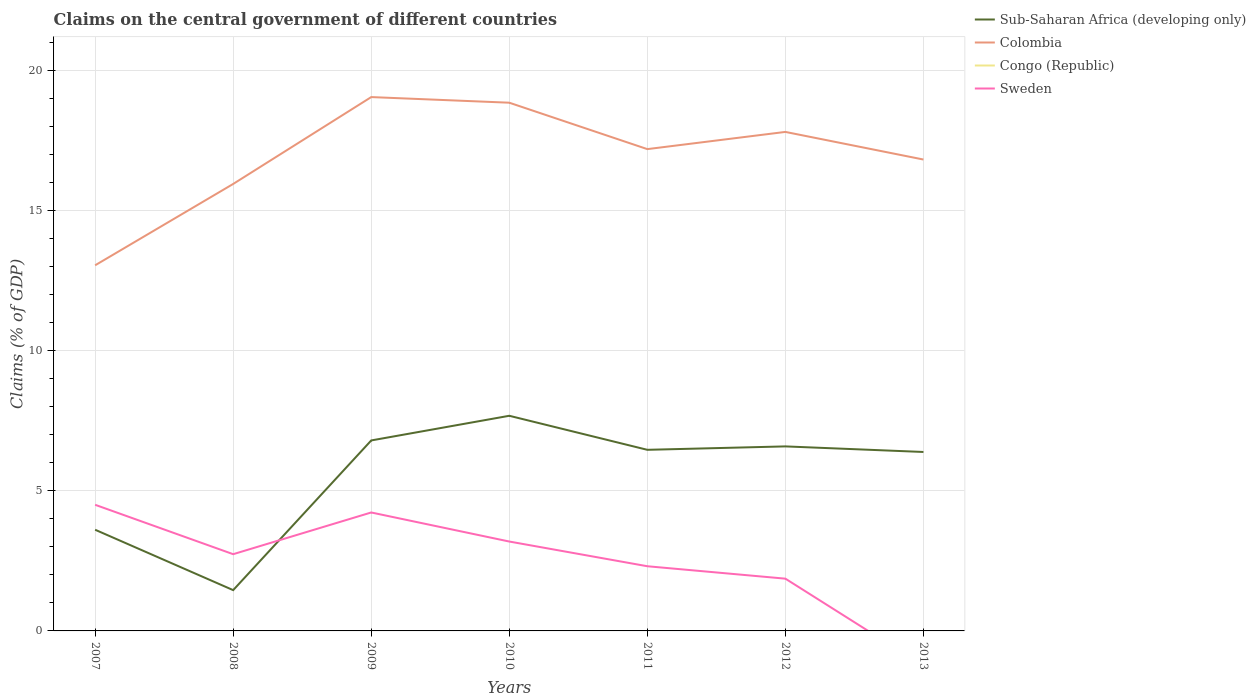How many different coloured lines are there?
Provide a succinct answer. 3. Is the number of lines equal to the number of legend labels?
Offer a terse response. No. Across all years, what is the maximum percentage of GDP claimed on the central government in Congo (Republic)?
Your response must be concise. 0. What is the total percentage of GDP claimed on the central government in Sub-Saharan Africa (developing only) in the graph?
Offer a very short reply. 0.21. What is the difference between the highest and the second highest percentage of GDP claimed on the central government in Colombia?
Offer a very short reply. 6. Are the values on the major ticks of Y-axis written in scientific E-notation?
Your response must be concise. No. Does the graph contain grids?
Make the answer very short. Yes. How are the legend labels stacked?
Provide a short and direct response. Vertical. What is the title of the graph?
Your response must be concise. Claims on the central government of different countries. What is the label or title of the X-axis?
Offer a terse response. Years. What is the label or title of the Y-axis?
Offer a very short reply. Claims (% of GDP). What is the Claims (% of GDP) of Sub-Saharan Africa (developing only) in 2007?
Give a very brief answer. 3.61. What is the Claims (% of GDP) of Colombia in 2007?
Offer a terse response. 13.04. What is the Claims (% of GDP) in Congo (Republic) in 2007?
Offer a very short reply. 0. What is the Claims (% of GDP) of Sweden in 2007?
Keep it short and to the point. 4.5. What is the Claims (% of GDP) of Sub-Saharan Africa (developing only) in 2008?
Provide a short and direct response. 1.46. What is the Claims (% of GDP) of Colombia in 2008?
Give a very brief answer. 15.95. What is the Claims (% of GDP) in Sweden in 2008?
Give a very brief answer. 2.74. What is the Claims (% of GDP) in Sub-Saharan Africa (developing only) in 2009?
Provide a short and direct response. 6.8. What is the Claims (% of GDP) in Colombia in 2009?
Make the answer very short. 19.05. What is the Claims (% of GDP) in Congo (Republic) in 2009?
Ensure brevity in your answer.  0. What is the Claims (% of GDP) of Sweden in 2009?
Provide a succinct answer. 4.23. What is the Claims (% of GDP) of Sub-Saharan Africa (developing only) in 2010?
Keep it short and to the point. 7.68. What is the Claims (% of GDP) of Colombia in 2010?
Your answer should be very brief. 18.84. What is the Claims (% of GDP) in Sweden in 2010?
Ensure brevity in your answer.  3.19. What is the Claims (% of GDP) of Sub-Saharan Africa (developing only) in 2011?
Make the answer very short. 6.46. What is the Claims (% of GDP) of Colombia in 2011?
Give a very brief answer. 17.19. What is the Claims (% of GDP) of Congo (Republic) in 2011?
Provide a succinct answer. 0. What is the Claims (% of GDP) of Sweden in 2011?
Your answer should be compact. 2.31. What is the Claims (% of GDP) of Sub-Saharan Africa (developing only) in 2012?
Provide a succinct answer. 6.58. What is the Claims (% of GDP) of Colombia in 2012?
Keep it short and to the point. 17.8. What is the Claims (% of GDP) of Congo (Republic) in 2012?
Keep it short and to the point. 0. What is the Claims (% of GDP) of Sweden in 2012?
Offer a terse response. 1.86. What is the Claims (% of GDP) in Sub-Saharan Africa (developing only) in 2013?
Your answer should be very brief. 6.38. What is the Claims (% of GDP) in Colombia in 2013?
Your answer should be very brief. 16.82. What is the Claims (% of GDP) in Congo (Republic) in 2013?
Give a very brief answer. 0. What is the Claims (% of GDP) of Sweden in 2013?
Your answer should be very brief. 0. Across all years, what is the maximum Claims (% of GDP) of Sub-Saharan Africa (developing only)?
Offer a terse response. 7.68. Across all years, what is the maximum Claims (% of GDP) of Colombia?
Keep it short and to the point. 19.05. Across all years, what is the maximum Claims (% of GDP) in Sweden?
Provide a short and direct response. 4.5. Across all years, what is the minimum Claims (% of GDP) in Sub-Saharan Africa (developing only)?
Your response must be concise. 1.46. Across all years, what is the minimum Claims (% of GDP) of Colombia?
Give a very brief answer. 13.04. Across all years, what is the minimum Claims (% of GDP) of Sweden?
Provide a succinct answer. 0. What is the total Claims (% of GDP) of Sub-Saharan Africa (developing only) in the graph?
Offer a terse response. 38.96. What is the total Claims (% of GDP) of Colombia in the graph?
Offer a very short reply. 118.69. What is the total Claims (% of GDP) in Sweden in the graph?
Offer a very short reply. 18.82. What is the difference between the Claims (% of GDP) in Sub-Saharan Africa (developing only) in 2007 and that in 2008?
Your answer should be compact. 2.15. What is the difference between the Claims (% of GDP) of Colombia in 2007 and that in 2008?
Offer a very short reply. -2.9. What is the difference between the Claims (% of GDP) of Sweden in 2007 and that in 2008?
Your answer should be very brief. 1.76. What is the difference between the Claims (% of GDP) in Sub-Saharan Africa (developing only) in 2007 and that in 2009?
Provide a succinct answer. -3.19. What is the difference between the Claims (% of GDP) in Colombia in 2007 and that in 2009?
Give a very brief answer. -6. What is the difference between the Claims (% of GDP) of Sweden in 2007 and that in 2009?
Your response must be concise. 0.27. What is the difference between the Claims (% of GDP) of Sub-Saharan Africa (developing only) in 2007 and that in 2010?
Offer a very short reply. -4.07. What is the difference between the Claims (% of GDP) of Colombia in 2007 and that in 2010?
Give a very brief answer. -5.8. What is the difference between the Claims (% of GDP) of Sweden in 2007 and that in 2010?
Your response must be concise. 1.31. What is the difference between the Claims (% of GDP) in Sub-Saharan Africa (developing only) in 2007 and that in 2011?
Make the answer very short. -2.85. What is the difference between the Claims (% of GDP) of Colombia in 2007 and that in 2011?
Provide a short and direct response. -4.14. What is the difference between the Claims (% of GDP) of Sweden in 2007 and that in 2011?
Your answer should be compact. 2.19. What is the difference between the Claims (% of GDP) of Sub-Saharan Africa (developing only) in 2007 and that in 2012?
Provide a succinct answer. -2.97. What is the difference between the Claims (% of GDP) of Colombia in 2007 and that in 2012?
Provide a short and direct response. -4.76. What is the difference between the Claims (% of GDP) in Sweden in 2007 and that in 2012?
Your answer should be compact. 2.64. What is the difference between the Claims (% of GDP) in Sub-Saharan Africa (developing only) in 2007 and that in 2013?
Give a very brief answer. -2.77. What is the difference between the Claims (% of GDP) in Colombia in 2007 and that in 2013?
Ensure brevity in your answer.  -3.77. What is the difference between the Claims (% of GDP) in Sub-Saharan Africa (developing only) in 2008 and that in 2009?
Your answer should be very brief. -5.34. What is the difference between the Claims (% of GDP) of Colombia in 2008 and that in 2009?
Your answer should be very brief. -3.1. What is the difference between the Claims (% of GDP) in Sweden in 2008 and that in 2009?
Make the answer very short. -1.49. What is the difference between the Claims (% of GDP) in Sub-Saharan Africa (developing only) in 2008 and that in 2010?
Keep it short and to the point. -6.22. What is the difference between the Claims (% of GDP) of Colombia in 2008 and that in 2010?
Your answer should be very brief. -2.9. What is the difference between the Claims (% of GDP) of Sweden in 2008 and that in 2010?
Provide a succinct answer. -0.45. What is the difference between the Claims (% of GDP) in Sub-Saharan Africa (developing only) in 2008 and that in 2011?
Your response must be concise. -5.01. What is the difference between the Claims (% of GDP) of Colombia in 2008 and that in 2011?
Offer a very short reply. -1.24. What is the difference between the Claims (% of GDP) of Sweden in 2008 and that in 2011?
Provide a succinct answer. 0.43. What is the difference between the Claims (% of GDP) in Sub-Saharan Africa (developing only) in 2008 and that in 2012?
Offer a terse response. -5.13. What is the difference between the Claims (% of GDP) of Colombia in 2008 and that in 2012?
Give a very brief answer. -1.86. What is the difference between the Claims (% of GDP) in Sweden in 2008 and that in 2012?
Give a very brief answer. 0.87. What is the difference between the Claims (% of GDP) in Sub-Saharan Africa (developing only) in 2008 and that in 2013?
Give a very brief answer. -4.93. What is the difference between the Claims (% of GDP) in Colombia in 2008 and that in 2013?
Ensure brevity in your answer.  -0.87. What is the difference between the Claims (% of GDP) of Sub-Saharan Africa (developing only) in 2009 and that in 2010?
Provide a succinct answer. -0.88. What is the difference between the Claims (% of GDP) of Colombia in 2009 and that in 2010?
Offer a terse response. 0.2. What is the difference between the Claims (% of GDP) of Sweden in 2009 and that in 2010?
Provide a short and direct response. 1.04. What is the difference between the Claims (% of GDP) of Sub-Saharan Africa (developing only) in 2009 and that in 2011?
Offer a terse response. 0.33. What is the difference between the Claims (% of GDP) in Colombia in 2009 and that in 2011?
Keep it short and to the point. 1.86. What is the difference between the Claims (% of GDP) of Sweden in 2009 and that in 2011?
Your answer should be compact. 1.92. What is the difference between the Claims (% of GDP) of Sub-Saharan Africa (developing only) in 2009 and that in 2012?
Offer a very short reply. 0.21. What is the difference between the Claims (% of GDP) of Colombia in 2009 and that in 2012?
Your answer should be compact. 1.24. What is the difference between the Claims (% of GDP) in Sweden in 2009 and that in 2012?
Your answer should be compact. 2.36. What is the difference between the Claims (% of GDP) of Sub-Saharan Africa (developing only) in 2009 and that in 2013?
Provide a succinct answer. 0.41. What is the difference between the Claims (% of GDP) in Colombia in 2009 and that in 2013?
Offer a very short reply. 2.23. What is the difference between the Claims (% of GDP) in Sub-Saharan Africa (developing only) in 2010 and that in 2011?
Your answer should be very brief. 1.21. What is the difference between the Claims (% of GDP) in Colombia in 2010 and that in 2011?
Keep it short and to the point. 1.66. What is the difference between the Claims (% of GDP) in Sweden in 2010 and that in 2011?
Your answer should be very brief. 0.88. What is the difference between the Claims (% of GDP) in Sub-Saharan Africa (developing only) in 2010 and that in 2012?
Offer a very short reply. 1.09. What is the difference between the Claims (% of GDP) of Colombia in 2010 and that in 2012?
Your answer should be compact. 1.04. What is the difference between the Claims (% of GDP) of Sweden in 2010 and that in 2012?
Offer a very short reply. 1.32. What is the difference between the Claims (% of GDP) of Sub-Saharan Africa (developing only) in 2010 and that in 2013?
Offer a terse response. 1.29. What is the difference between the Claims (% of GDP) in Colombia in 2010 and that in 2013?
Your response must be concise. 2.03. What is the difference between the Claims (% of GDP) of Sub-Saharan Africa (developing only) in 2011 and that in 2012?
Keep it short and to the point. -0.12. What is the difference between the Claims (% of GDP) of Colombia in 2011 and that in 2012?
Keep it short and to the point. -0.61. What is the difference between the Claims (% of GDP) of Sweden in 2011 and that in 2012?
Keep it short and to the point. 0.44. What is the difference between the Claims (% of GDP) in Sub-Saharan Africa (developing only) in 2011 and that in 2013?
Offer a very short reply. 0.08. What is the difference between the Claims (% of GDP) of Colombia in 2011 and that in 2013?
Keep it short and to the point. 0.37. What is the difference between the Claims (% of GDP) in Sub-Saharan Africa (developing only) in 2012 and that in 2013?
Keep it short and to the point. 0.2. What is the difference between the Claims (% of GDP) of Colombia in 2012 and that in 2013?
Your answer should be very brief. 0.99. What is the difference between the Claims (% of GDP) of Sub-Saharan Africa (developing only) in 2007 and the Claims (% of GDP) of Colombia in 2008?
Provide a short and direct response. -12.34. What is the difference between the Claims (% of GDP) in Sub-Saharan Africa (developing only) in 2007 and the Claims (% of GDP) in Sweden in 2008?
Give a very brief answer. 0.87. What is the difference between the Claims (% of GDP) in Colombia in 2007 and the Claims (% of GDP) in Sweden in 2008?
Your answer should be very brief. 10.31. What is the difference between the Claims (% of GDP) of Sub-Saharan Africa (developing only) in 2007 and the Claims (% of GDP) of Colombia in 2009?
Give a very brief answer. -15.44. What is the difference between the Claims (% of GDP) of Sub-Saharan Africa (developing only) in 2007 and the Claims (% of GDP) of Sweden in 2009?
Give a very brief answer. -0.62. What is the difference between the Claims (% of GDP) in Colombia in 2007 and the Claims (% of GDP) in Sweden in 2009?
Your response must be concise. 8.82. What is the difference between the Claims (% of GDP) of Sub-Saharan Africa (developing only) in 2007 and the Claims (% of GDP) of Colombia in 2010?
Provide a succinct answer. -15.23. What is the difference between the Claims (% of GDP) in Sub-Saharan Africa (developing only) in 2007 and the Claims (% of GDP) in Sweden in 2010?
Your answer should be very brief. 0.42. What is the difference between the Claims (% of GDP) in Colombia in 2007 and the Claims (% of GDP) in Sweden in 2010?
Your answer should be very brief. 9.85. What is the difference between the Claims (% of GDP) in Sub-Saharan Africa (developing only) in 2007 and the Claims (% of GDP) in Colombia in 2011?
Keep it short and to the point. -13.58. What is the difference between the Claims (% of GDP) of Sub-Saharan Africa (developing only) in 2007 and the Claims (% of GDP) of Sweden in 2011?
Offer a terse response. 1.3. What is the difference between the Claims (% of GDP) in Colombia in 2007 and the Claims (% of GDP) in Sweden in 2011?
Keep it short and to the point. 10.74. What is the difference between the Claims (% of GDP) of Sub-Saharan Africa (developing only) in 2007 and the Claims (% of GDP) of Colombia in 2012?
Your response must be concise. -14.19. What is the difference between the Claims (% of GDP) of Sub-Saharan Africa (developing only) in 2007 and the Claims (% of GDP) of Sweden in 2012?
Your response must be concise. 1.75. What is the difference between the Claims (% of GDP) in Colombia in 2007 and the Claims (% of GDP) in Sweden in 2012?
Give a very brief answer. 11.18. What is the difference between the Claims (% of GDP) in Sub-Saharan Africa (developing only) in 2007 and the Claims (% of GDP) in Colombia in 2013?
Your answer should be compact. -13.21. What is the difference between the Claims (% of GDP) of Sub-Saharan Africa (developing only) in 2008 and the Claims (% of GDP) of Colombia in 2009?
Give a very brief answer. -17.59. What is the difference between the Claims (% of GDP) of Sub-Saharan Africa (developing only) in 2008 and the Claims (% of GDP) of Sweden in 2009?
Your response must be concise. -2.77. What is the difference between the Claims (% of GDP) of Colombia in 2008 and the Claims (% of GDP) of Sweden in 2009?
Ensure brevity in your answer.  11.72. What is the difference between the Claims (% of GDP) of Sub-Saharan Africa (developing only) in 2008 and the Claims (% of GDP) of Colombia in 2010?
Keep it short and to the point. -17.39. What is the difference between the Claims (% of GDP) of Sub-Saharan Africa (developing only) in 2008 and the Claims (% of GDP) of Sweden in 2010?
Your answer should be very brief. -1.73. What is the difference between the Claims (% of GDP) of Colombia in 2008 and the Claims (% of GDP) of Sweden in 2010?
Offer a terse response. 12.76. What is the difference between the Claims (% of GDP) of Sub-Saharan Africa (developing only) in 2008 and the Claims (% of GDP) of Colombia in 2011?
Give a very brief answer. -15.73. What is the difference between the Claims (% of GDP) in Sub-Saharan Africa (developing only) in 2008 and the Claims (% of GDP) in Sweden in 2011?
Your answer should be compact. -0.85. What is the difference between the Claims (% of GDP) in Colombia in 2008 and the Claims (% of GDP) in Sweden in 2011?
Ensure brevity in your answer.  13.64. What is the difference between the Claims (% of GDP) of Sub-Saharan Africa (developing only) in 2008 and the Claims (% of GDP) of Colombia in 2012?
Ensure brevity in your answer.  -16.35. What is the difference between the Claims (% of GDP) in Sub-Saharan Africa (developing only) in 2008 and the Claims (% of GDP) in Sweden in 2012?
Give a very brief answer. -0.41. What is the difference between the Claims (% of GDP) in Colombia in 2008 and the Claims (% of GDP) in Sweden in 2012?
Your answer should be compact. 14.08. What is the difference between the Claims (% of GDP) of Sub-Saharan Africa (developing only) in 2008 and the Claims (% of GDP) of Colombia in 2013?
Make the answer very short. -15.36. What is the difference between the Claims (% of GDP) in Sub-Saharan Africa (developing only) in 2009 and the Claims (% of GDP) in Colombia in 2010?
Make the answer very short. -12.05. What is the difference between the Claims (% of GDP) in Sub-Saharan Africa (developing only) in 2009 and the Claims (% of GDP) in Sweden in 2010?
Provide a succinct answer. 3.61. What is the difference between the Claims (% of GDP) in Colombia in 2009 and the Claims (% of GDP) in Sweden in 2010?
Give a very brief answer. 15.86. What is the difference between the Claims (% of GDP) of Sub-Saharan Africa (developing only) in 2009 and the Claims (% of GDP) of Colombia in 2011?
Your answer should be compact. -10.39. What is the difference between the Claims (% of GDP) of Sub-Saharan Africa (developing only) in 2009 and the Claims (% of GDP) of Sweden in 2011?
Keep it short and to the point. 4.49. What is the difference between the Claims (% of GDP) in Colombia in 2009 and the Claims (% of GDP) in Sweden in 2011?
Your answer should be very brief. 16.74. What is the difference between the Claims (% of GDP) of Sub-Saharan Africa (developing only) in 2009 and the Claims (% of GDP) of Colombia in 2012?
Make the answer very short. -11.01. What is the difference between the Claims (% of GDP) in Sub-Saharan Africa (developing only) in 2009 and the Claims (% of GDP) in Sweden in 2012?
Your answer should be compact. 4.93. What is the difference between the Claims (% of GDP) in Colombia in 2009 and the Claims (% of GDP) in Sweden in 2012?
Offer a terse response. 17.18. What is the difference between the Claims (% of GDP) in Sub-Saharan Africa (developing only) in 2009 and the Claims (% of GDP) in Colombia in 2013?
Keep it short and to the point. -10.02. What is the difference between the Claims (% of GDP) in Sub-Saharan Africa (developing only) in 2010 and the Claims (% of GDP) in Colombia in 2011?
Your answer should be very brief. -9.51. What is the difference between the Claims (% of GDP) in Sub-Saharan Africa (developing only) in 2010 and the Claims (% of GDP) in Sweden in 2011?
Provide a succinct answer. 5.37. What is the difference between the Claims (% of GDP) in Colombia in 2010 and the Claims (% of GDP) in Sweden in 2011?
Provide a short and direct response. 16.54. What is the difference between the Claims (% of GDP) in Sub-Saharan Africa (developing only) in 2010 and the Claims (% of GDP) in Colombia in 2012?
Your answer should be compact. -10.13. What is the difference between the Claims (% of GDP) of Sub-Saharan Africa (developing only) in 2010 and the Claims (% of GDP) of Sweden in 2012?
Offer a terse response. 5.81. What is the difference between the Claims (% of GDP) in Colombia in 2010 and the Claims (% of GDP) in Sweden in 2012?
Your answer should be compact. 16.98. What is the difference between the Claims (% of GDP) in Sub-Saharan Africa (developing only) in 2010 and the Claims (% of GDP) in Colombia in 2013?
Make the answer very short. -9.14. What is the difference between the Claims (% of GDP) in Sub-Saharan Africa (developing only) in 2011 and the Claims (% of GDP) in Colombia in 2012?
Your answer should be very brief. -11.34. What is the difference between the Claims (% of GDP) of Sub-Saharan Africa (developing only) in 2011 and the Claims (% of GDP) of Sweden in 2012?
Give a very brief answer. 4.6. What is the difference between the Claims (% of GDP) of Colombia in 2011 and the Claims (% of GDP) of Sweden in 2012?
Keep it short and to the point. 15.32. What is the difference between the Claims (% of GDP) in Sub-Saharan Africa (developing only) in 2011 and the Claims (% of GDP) in Colombia in 2013?
Keep it short and to the point. -10.36. What is the difference between the Claims (% of GDP) of Sub-Saharan Africa (developing only) in 2012 and the Claims (% of GDP) of Colombia in 2013?
Your answer should be compact. -10.23. What is the average Claims (% of GDP) of Sub-Saharan Africa (developing only) per year?
Give a very brief answer. 5.57. What is the average Claims (% of GDP) of Colombia per year?
Ensure brevity in your answer.  16.96. What is the average Claims (% of GDP) of Congo (Republic) per year?
Offer a very short reply. 0. What is the average Claims (% of GDP) of Sweden per year?
Your answer should be compact. 2.69. In the year 2007, what is the difference between the Claims (% of GDP) in Sub-Saharan Africa (developing only) and Claims (% of GDP) in Colombia?
Provide a succinct answer. -9.43. In the year 2007, what is the difference between the Claims (% of GDP) of Sub-Saharan Africa (developing only) and Claims (% of GDP) of Sweden?
Offer a very short reply. -0.89. In the year 2007, what is the difference between the Claims (% of GDP) in Colombia and Claims (% of GDP) in Sweden?
Make the answer very short. 8.54. In the year 2008, what is the difference between the Claims (% of GDP) of Sub-Saharan Africa (developing only) and Claims (% of GDP) of Colombia?
Provide a succinct answer. -14.49. In the year 2008, what is the difference between the Claims (% of GDP) of Sub-Saharan Africa (developing only) and Claims (% of GDP) of Sweden?
Your response must be concise. -1.28. In the year 2008, what is the difference between the Claims (% of GDP) of Colombia and Claims (% of GDP) of Sweden?
Your response must be concise. 13.21. In the year 2009, what is the difference between the Claims (% of GDP) in Sub-Saharan Africa (developing only) and Claims (% of GDP) in Colombia?
Your response must be concise. -12.25. In the year 2009, what is the difference between the Claims (% of GDP) of Sub-Saharan Africa (developing only) and Claims (% of GDP) of Sweden?
Make the answer very short. 2.57. In the year 2009, what is the difference between the Claims (% of GDP) in Colombia and Claims (% of GDP) in Sweden?
Your response must be concise. 14.82. In the year 2010, what is the difference between the Claims (% of GDP) in Sub-Saharan Africa (developing only) and Claims (% of GDP) in Colombia?
Offer a terse response. -11.17. In the year 2010, what is the difference between the Claims (% of GDP) of Sub-Saharan Africa (developing only) and Claims (% of GDP) of Sweden?
Give a very brief answer. 4.49. In the year 2010, what is the difference between the Claims (% of GDP) of Colombia and Claims (% of GDP) of Sweden?
Offer a very short reply. 15.66. In the year 2011, what is the difference between the Claims (% of GDP) of Sub-Saharan Africa (developing only) and Claims (% of GDP) of Colombia?
Provide a short and direct response. -10.73. In the year 2011, what is the difference between the Claims (% of GDP) of Sub-Saharan Africa (developing only) and Claims (% of GDP) of Sweden?
Offer a terse response. 4.15. In the year 2011, what is the difference between the Claims (% of GDP) of Colombia and Claims (% of GDP) of Sweden?
Make the answer very short. 14.88. In the year 2012, what is the difference between the Claims (% of GDP) in Sub-Saharan Africa (developing only) and Claims (% of GDP) in Colombia?
Provide a succinct answer. -11.22. In the year 2012, what is the difference between the Claims (% of GDP) of Sub-Saharan Africa (developing only) and Claims (% of GDP) of Sweden?
Provide a succinct answer. 4.72. In the year 2012, what is the difference between the Claims (% of GDP) in Colombia and Claims (% of GDP) in Sweden?
Offer a terse response. 15.94. In the year 2013, what is the difference between the Claims (% of GDP) of Sub-Saharan Africa (developing only) and Claims (% of GDP) of Colombia?
Ensure brevity in your answer.  -10.43. What is the ratio of the Claims (% of GDP) in Sub-Saharan Africa (developing only) in 2007 to that in 2008?
Provide a succinct answer. 2.48. What is the ratio of the Claims (% of GDP) in Colombia in 2007 to that in 2008?
Your answer should be compact. 0.82. What is the ratio of the Claims (% of GDP) in Sweden in 2007 to that in 2008?
Make the answer very short. 1.64. What is the ratio of the Claims (% of GDP) in Sub-Saharan Africa (developing only) in 2007 to that in 2009?
Ensure brevity in your answer.  0.53. What is the ratio of the Claims (% of GDP) in Colombia in 2007 to that in 2009?
Offer a terse response. 0.68. What is the ratio of the Claims (% of GDP) in Sweden in 2007 to that in 2009?
Your answer should be compact. 1.06. What is the ratio of the Claims (% of GDP) in Sub-Saharan Africa (developing only) in 2007 to that in 2010?
Offer a very short reply. 0.47. What is the ratio of the Claims (% of GDP) of Colombia in 2007 to that in 2010?
Offer a terse response. 0.69. What is the ratio of the Claims (% of GDP) of Sweden in 2007 to that in 2010?
Provide a short and direct response. 1.41. What is the ratio of the Claims (% of GDP) in Sub-Saharan Africa (developing only) in 2007 to that in 2011?
Ensure brevity in your answer.  0.56. What is the ratio of the Claims (% of GDP) of Colombia in 2007 to that in 2011?
Keep it short and to the point. 0.76. What is the ratio of the Claims (% of GDP) in Sweden in 2007 to that in 2011?
Offer a terse response. 1.95. What is the ratio of the Claims (% of GDP) of Sub-Saharan Africa (developing only) in 2007 to that in 2012?
Ensure brevity in your answer.  0.55. What is the ratio of the Claims (% of GDP) of Colombia in 2007 to that in 2012?
Ensure brevity in your answer.  0.73. What is the ratio of the Claims (% of GDP) of Sweden in 2007 to that in 2012?
Your answer should be compact. 2.41. What is the ratio of the Claims (% of GDP) of Sub-Saharan Africa (developing only) in 2007 to that in 2013?
Your answer should be compact. 0.57. What is the ratio of the Claims (% of GDP) in Colombia in 2007 to that in 2013?
Make the answer very short. 0.78. What is the ratio of the Claims (% of GDP) in Sub-Saharan Africa (developing only) in 2008 to that in 2009?
Your answer should be compact. 0.21. What is the ratio of the Claims (% of GDP) in Colombia in 2008 to that in 2009?
Your answer should be very brief. 0.84. What is the ratio of the Claims (% of GDP) in Sweden in 2008 to that in 2009?
Ensure brevity in your answer.  0.65. What is the ratio of the Claims (% of GDP) in Sub-Saharan Africa (developing only) in 2008 to that in 2010?
Your answer should be compact. 0.19. What is the ratio of the Claims (% of GDP) in Colombia in 2008 to that in 2010?
Offer a terse response. 0.85. What is the ratio of the Claims (% of GDP) of Sweden in 2008 to that in 2010?
Give a very brief answer. 0.86. What is the ratio of the Claims (% of GDP) in Sub-Saharan Africa (developing only) in 2008 to that in 2011?
Make the answer very short. 0.23. What is the ratio of the Claims (% of GDP) in Colombia in 2008 to that in 2011?
Ensure brevity in your answer.  0.93. What is the ratio of the Claims (% of GDP) of Sweden in 2008 to that in 2011?
Keep it short and to the point. 1.19. What is the ratio of the Claims (% of GDP) of Sub-Saharan Africa (developing only) in 2008 to that in 2012?
Keep it short and to the point. 0.22. What is the ratio of the Claims (% of GDP) in Colombia in 2008 to that in 2012?
Your answer should be very brief. 0.9. What is the ratio of the Claims (% of GDP) in Sweden in 2008 to that in 2012?
Offer a very short reply. 1.47. What is the ratio of the Claims (% of GDP) of Sub-Saharan Africa (developing only) in 2008 to that in 2013?
Ensure brevity in your answer.  0.23. What is the ratio of the Claims (% of GDP) of Colombia in 2008 to that in 2013?
Your answer should be very brief. 0.95. What is the ratio of the Claims (% of GDP) of Sub-Saharan Africa (developing only) in 2009 to that in 2010?
Give a very brief answer. 0.89. What is the ratio of the Claims (% of GDP) of Colombia in 2009 to that in 2010?
Your answer should be very brief. 1.01. What is the ratio of the Claims (% of GDP) in Sweden in 2009 to that in 2010?
Offer a very short reply. 1.32. What is the ratio of the Claims (% of GDP) of Sub-Saharan Africa (developing only) in 2009 to that in 2011?
Your response must be concise. 1.05. What is the ratio of the Claims (% of GDP) of Colombia in 2009 to that in 2011?
Offer a terse response. 1.11. What is the ratio of the Claims (% of GDP) in Sweden in 2009 to that in 2011?
Offer a very short reply. 1.83. What is the ratio of the Claims (% of GDP) in Sub-Saharan Africa (developing only) in 2009 to that in 2012?
Give a very brief answer. 1.03. What is the ratio of the Claims (% of GDP) of Colombia in 2009 to that in 2012?
Offer a terse response. 1.07. What is the ratio of the Claims (% of GDP) of Sweden in 2009 to that in 2012?
Provide a succinct answer. 2.27. What is the ratio of the Claims (% of GDP) in Sub-Saharan Africa (developing only) in 2009 to that in 2013?
Offer a very short reply. 1.06. What is the ratio of the Claims (% of GDP) of Colombia in 2009 to that in 2013?
Make the answer very short. 1.13. What is the ratio of the Claims (% of GDP) in Sub-Saharan Africa (developing only) in 2010 to that in 2011?
Provide a succinct answer. 1.19. What is the ratio of the Claims (% of GDP) in Colombia in 2010 to that in 2011?
Offer a terse response. 1.1. What is the ratio of the Claims (% of GDP) of Sweden in 2010 to that in 2011?
Offer a terse response. 1.38. What is the ratio of the Claims (% of GDP) in Sub-Saharan Africa (developing only) in 2010 to that in 2012?
Your response must be concise. 1.17. What is the ratio of the Claims (% of GDP) in Colombia in 2010 to that in 2012?
Provide a short and direct response. 1.06. What is the ratio of the Claims (% of GDP) of Sweden in 2010 to that in 2012?
Offer a very short reply. 1.71. What is the ratio of the Claims (% of GDP) of Sub-Saharan Africa (developing only) in 2010 to that in 2013?
Ensure brevity in your answer.  1.2. What is the ratio of the Claims (% of GDP) in Colombia in 2010 to that in 2013?
Offer a terse response. 1.12. What is the ratio of the Claims (% of GDP) in Sub-Saharan Africa (developing only) in 2011 to that in 2012?
Your answer should be compact. 0.98. What is the ratio of the Claims (% of GDP) in Colombia in 2011 to that in 2012?
Your answer should be compact. 0.97. What is the ratio of the Claims (% of GDP) in Sweden in 2011 to that in 2012?
Your response must be concise. 1.24. What is the ratio of the Claims (% of GDP) in Sub-Saharan Africa (developing only) in 2011 to that in 2013?
Your answer should be compact. 1.01. What is the ratio of the Claims (% of GDP) of Colombia in 2011 to that in 2013?
Your answer should be compact. 1.02. What is the ratio of the Claims (% of GDP) of Sub-Saharan Africa (developing only) in 2012 to that in 2013?
Your answer should be very brief. 1.03. What is the ratio of the Claims (% of GDP) in Colombia in 2012 to that in 2013?
Make the answer very short. 1.06. What is the difference between the highest and the second highest Claims (% of GDP) of Sub-Saharan Africa (developing only)?
Ensure brevity in your answer.  0.88. What is the difference between the highest and the second highest Claims (% of GDP) of Colombia?
Ensure brevity in your answer.  0.2. What is the difference between the highest and the second highest Claims (% of GDP) of Sweden?
Make the answer very short. 0.27. What is the difference between the highest and the lowest Claims (% of GDP) in Sub-Saharan Africa (developing only)?
Provide a succinct answer. 6.22. What is the difference between the highest and the lowest Claims (% of GDP) in Colombia?
Your response must be concise. 6. What is the difference between the highest and the lowest Claims (% of GDP) of Sweden?
Ensure brevity in your answer.  4.5. 